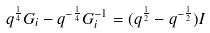<formula> <loc_0><loc_0><loc_500><loc_500>q ^ { \frac { 1 } { 4 } } G _ { i } - q ^ { - \frac { 1 } { 4 } } G _ { i } ^ { - 1 } = ( q ^ { \frac { 1 } { 2 } } - q ^ { - \frac { 1 } { 2 } } ) I</formula> 